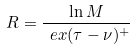Convert formula to latex. <formula><loc_0><loc_0><loc_500><loc_500>R = \frac { \ln M } { \ e x ( \tau - \nu ) ^ { + } }</formula> 